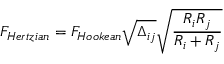<formula> <loc_0><loc_0><loc_500><loc_500>F _ { H e r t z i a n } = F _ { H o o k e a n } \sqrt { \Delta _ { i j } } \sqrt { \frac { R _ { i } R _ { j } } { R _ { i } + R _ { j } } }</formula> 